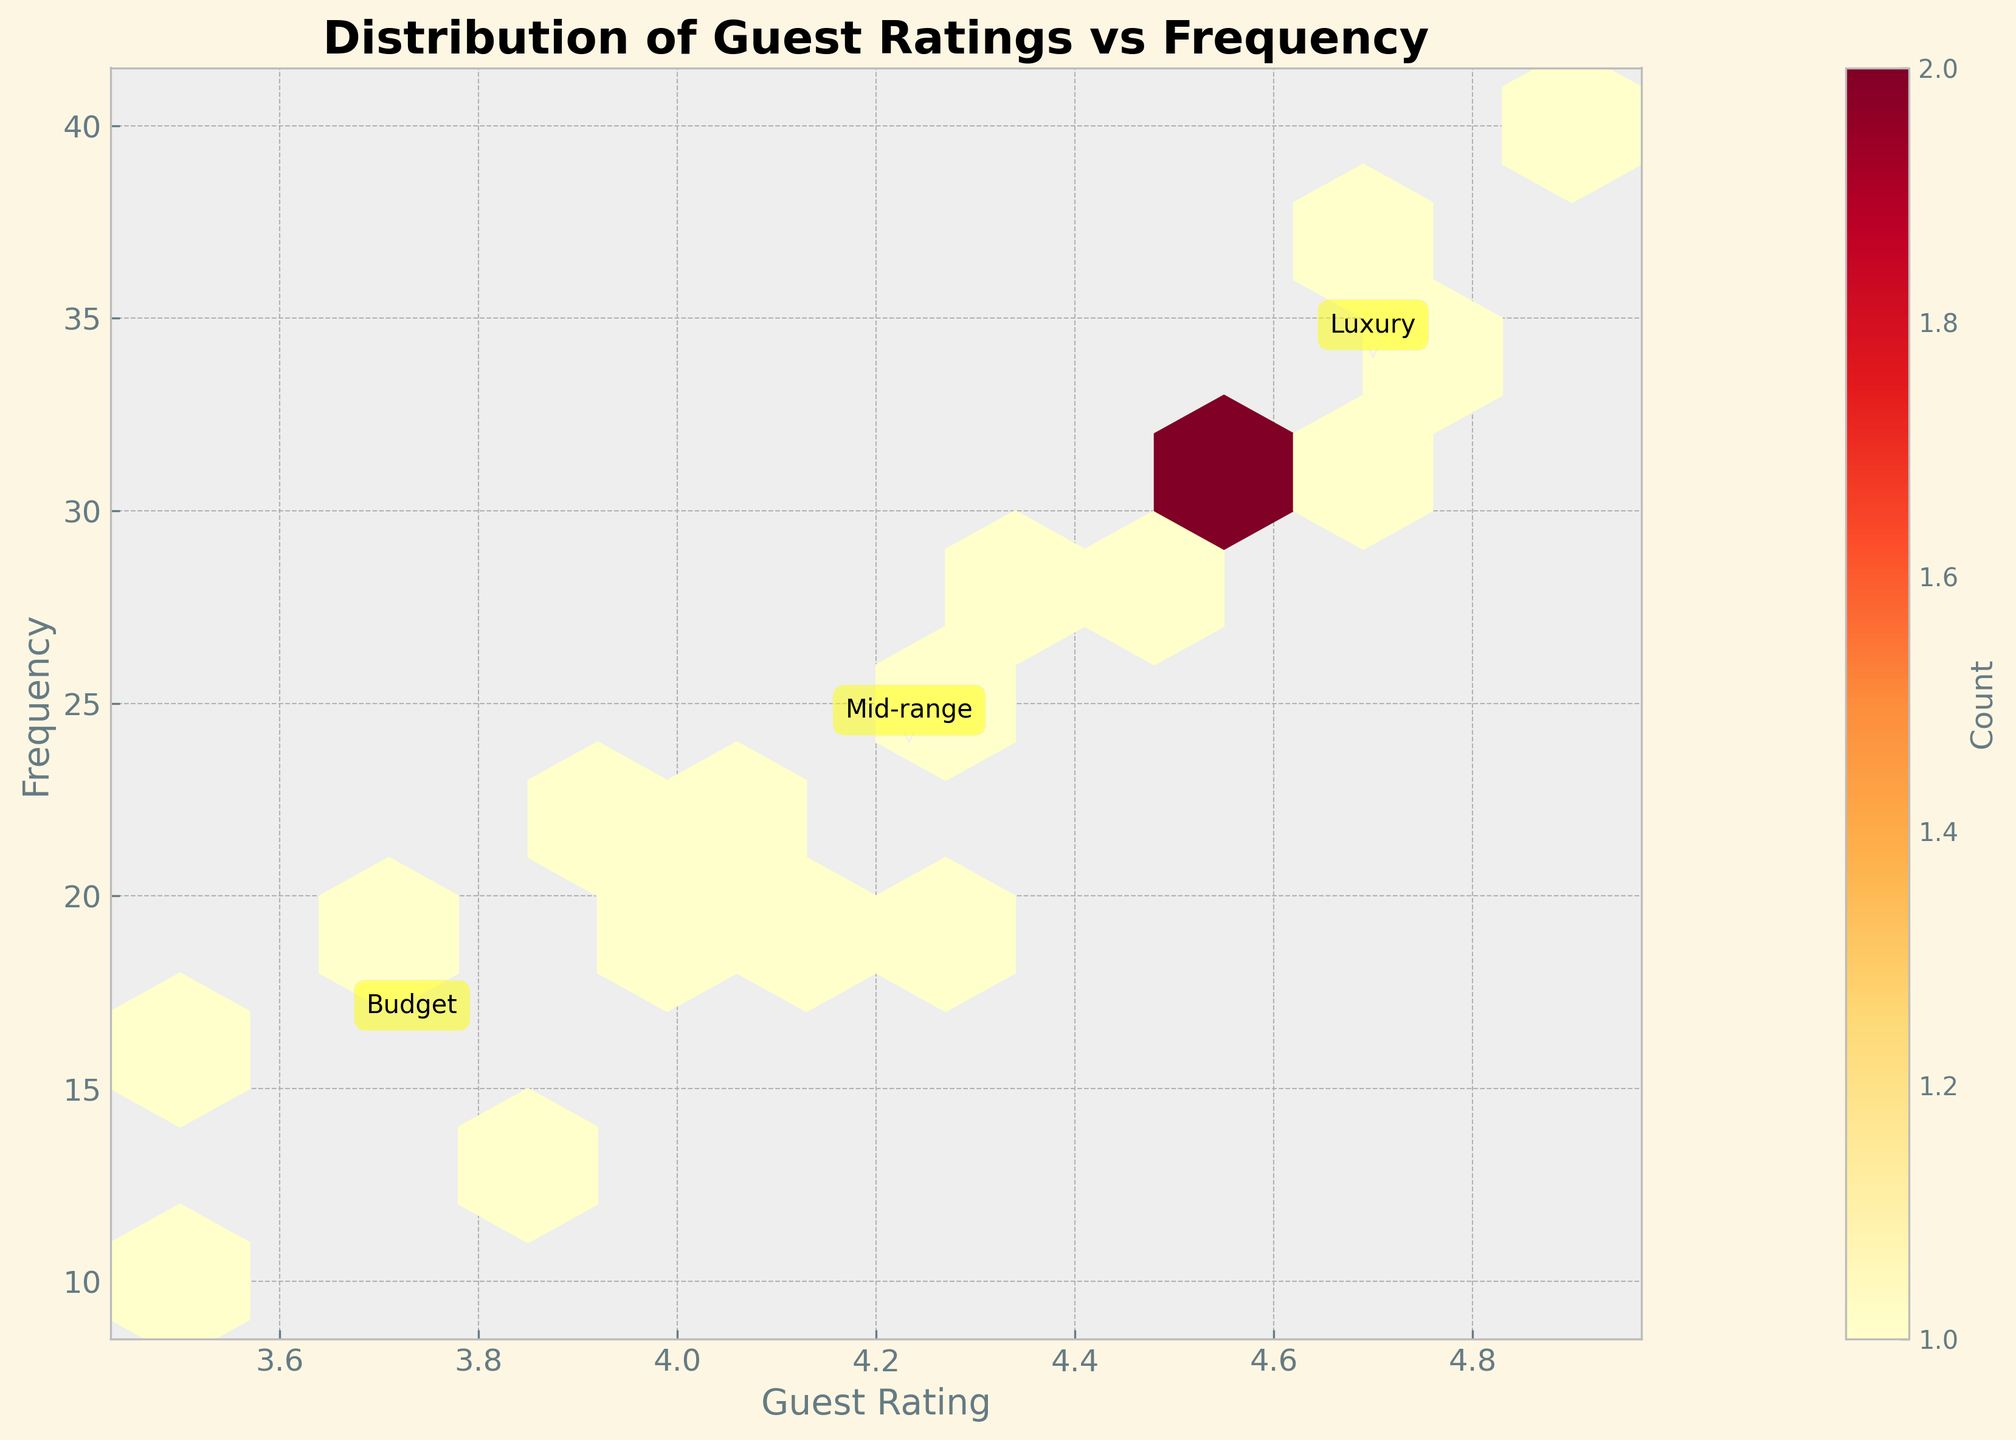What's the title of the figure? The title of the figure is prominently displayed at the top, usually in bold or larger font compared to the rest of the text.
Answer: Distribution of Guest Ratings vs Frequency What are the axes labeled? The labels of the axes are displayed next to the axes. For the horizontal axis, the label includes "Guest Rating," and for the vertical axis, the label is "Frequency."
Answer: Guest Rating and Frequency Which price range seems to have the highest average guest rating? By looking at the annotations near the higher guest rating areas, we can see that the "Luxury" price range has the highest average guest rating because it occupies the highest region on the Guest Rating axis.
Answer: Luxury What does the color intensity in the hexbin plot signify? The color intensity is represented in a hexbin plot to show the density or frequency of data points. The more intense the color, the higher the count of occurrences in that bin.
Answer: Count of occurrences Which season has higher guest ratings for the Mid-range price category? By comparing the annotated sections for the Mid-range in both high and low seasons, we see that the high season has guest ratings closer to 4.5, while the low season has ratings closer to 4.0. Thus, the high season has higher guest ratings.
Answer: High season Between Budget and Mid-range price ranges, which one shows a higher frequency of guest ratings around 4.0? Inspect the hexbin plot around the guest rating of 4.0 and compare the annotated frequencies. The Budget price range annotation is closer to higher frequency areas around 4.0, indicating that it has a higher frequency compared to Mid-range.
Answer: Budget How does guest rating for amenities compare in the high season versus the low season in the Luxury price range? By examining the annotated sections for the Luxury price range, we see that in both high and low seasons, guest ratings are very high (close to 4.8 and 4.6, respectively). The high season has slightly higher ratings than the low season.
Answer: High season has slightly higher Where is the highest concentration of guest rating data points located? By looking at the area with the most intense color in the hexbin plot, we can determine the highest concentration of data points. This area is around a guest rating of 4.5 and a frequency of 40, which corresponds to the Luxury price range.
Answer: Around 4.5 and 40 frequency What is the relationship between frequency and guest rating according to the plot? The hexbin plot shows data points that indicate as the guest ratings increase, the frequency of those ratings also increases, particularly in the higher price ranges. This suggests that better-rated amenities are used more frequently.
Answer: Higher guest ratings have higher frequencies Which amenity in the budget category during the high season has the lowest guest rating? The data shows the guest ratings for amenities in different categories and seasons. In the high season for the Budget category, "Pool" has a rating of 3.5 which is lower compared to other amenities in the same range and season.
Answer: Pool 